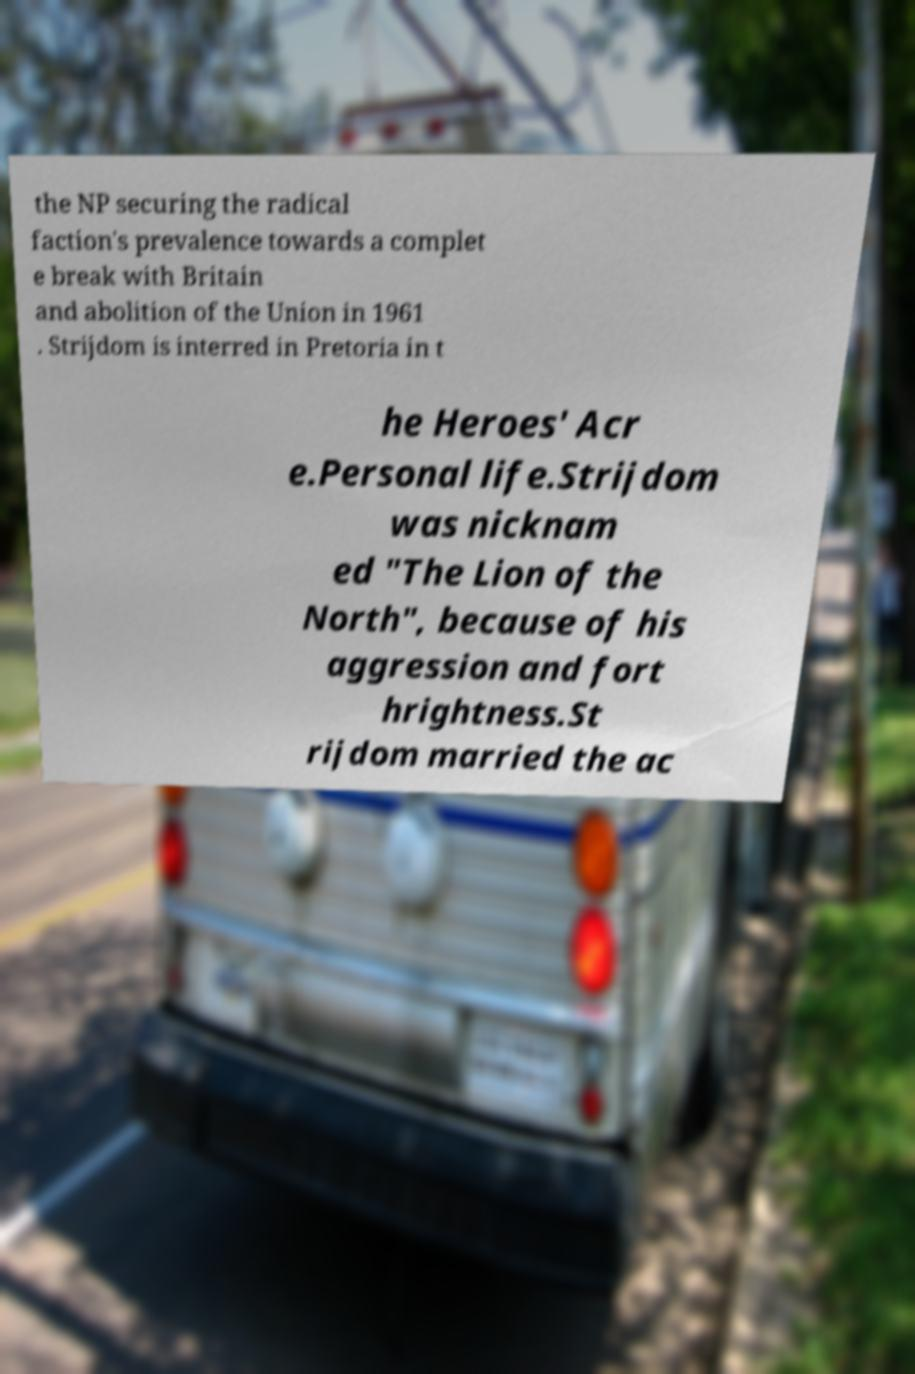Can you accurately transcribe the text from the provided image for me? the NP securing the radical faction's prevalence towards a complet e break with Britain and abolition of the Union in 1961 . Strijdom is interred in Pretoria in t he Heroes' Acr e.Personal life.Strijdom was nicknam ed "The Lion of the North", because of his aggression and fort hrightness.St rijdom married the ac 